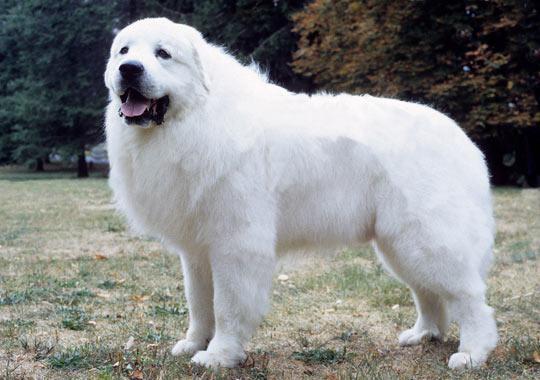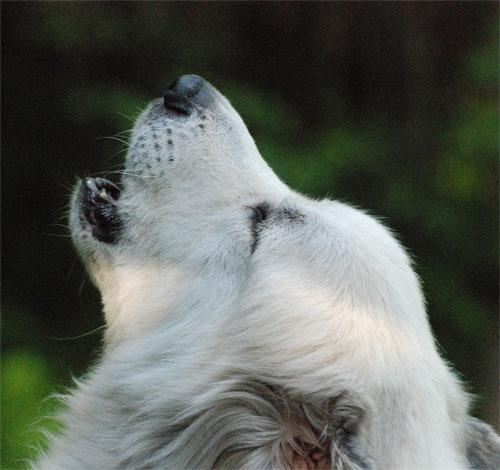The first image is the image on the left, the second image is the image on the right. Assess this claim about the two images: "The dog in the image on the left is running through the grass.". Correct or not? Answer yes or no. No. The first image is the image on the left, the second image is the image on the right. Given the left and right images, does the statement "An image shows a dog running across the grass with its tongue sticking out and to one side." hold true? Answer yes or no. No. 